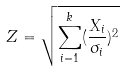Convert formula to latex. <formula><loc_0><loc_0><loc_500><loc_500>Z = \sqrt { \sum _ { i = 1 } ^ { k } ( \frac { X _ { i } } { \sigma _ { i } } ) ^ { 2 } }</formula> 